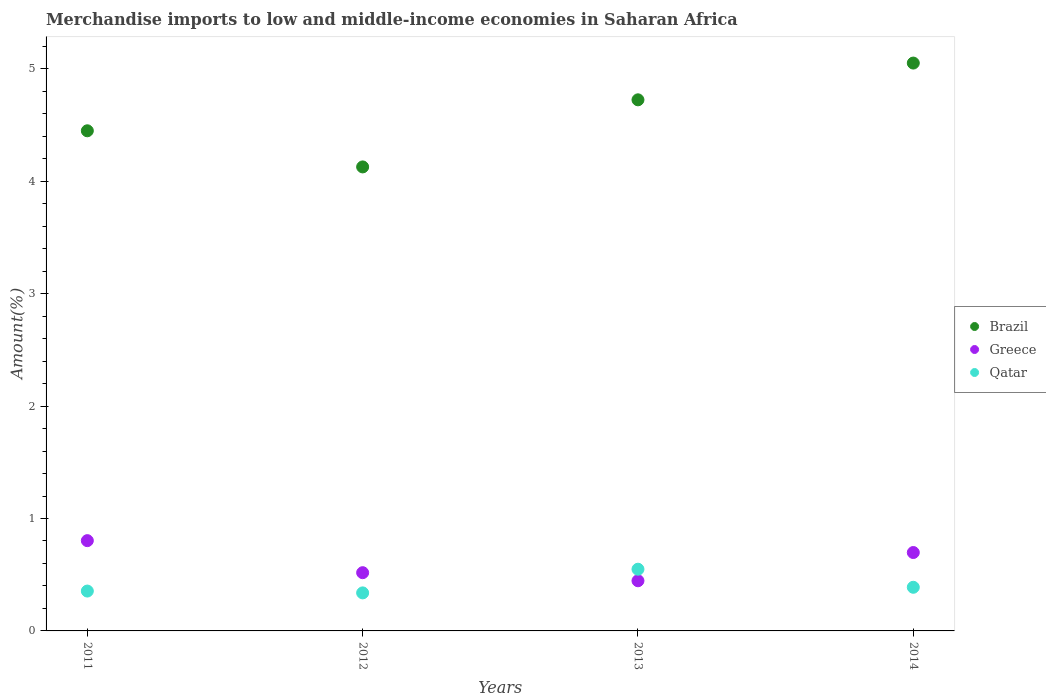How many different coloured dotlines are there?
Provide a succinct answer. 3. Is the number of dotlines equal to the number of legend labels?
Offer a very short reply. Yes. What is the percentage of amount earned from merchandise imports in Qatar in 2014?
Keep it short and to the point. 0.39. Across all years, what is the maximum percentage of amount earned from merchandise imports in Greece?
Keep it short and to the point. 0.8. Across all years, what is the minimum percentage of amount earned from merchandise imports in Greece?
Keep it short and to the point. 0.45. What is the total percentage of amount earned from merchandise imports in Qatar in the graph?
Provide a succinct answer. 1.63. What is the difference between the percentage of amount earned from merchandise imports in Qatar in 2012 and that in 2013?
Provide a short and direct response. -0.21. What is the difference between the percentage of amount earned from merchandise imports in Brazil in 2011 and the percentage of amount earned from merchandise imports in Qatar in 2013?
Offer a very short reply. 3.9. What is the average percentage of amount earned from merchandise imports in Greece per year?
Keep it short and to the point. 0.62. In the year 2013, what is the difference between the percentage of amount earned from merchandise imports in Qatar and percentage of amount earned from merchandise imports in Greece?
Your answer should be very brief. 0.1. In how many years, is the percentage of amount earned from merchandise imports in Greece greater than 4 %?
Your answer should be compact. 0. What is the ratio of the percentage of amount earned from merchandise imports in Brazil in 2012 to that in 2014?
Your answer should be compact. 0.82. Is the percentage of amount earned from merchandise imports in Qatar in 2012 less than that in 2014?
Provide a succinct answer. Yes. Is the difference between the percentage of amount earned from merchandise imports in Qatar in 2012 and 2014 greater than the difference between the percentage of amount earned from merchandise imports in Greece in 2012 and 2014?
Your answer should be very brief. Yes. What is the difference between the highest and the second highest percentage of amount earned from merchandise imports in Greece?
Ensure brevity in your answer.  0.11. What is the difference between the highest and the lowest percentage of amount earned from merchandise imports in Qatar?
Offer a very short reply. 0.21. Does the percentage of amount earned from merchandise imports in Greece monotonically increase over the years?
Ensure brevity in your answer.  No. Is the percentage of amount earned from merchandise imports in Brazil strictly less than the percentage of amount earned from merchandise imports in Qatar over the years?
Your response must be concise. No. How many years are there in the graph?
Your answer should be compact. 4. Are the values on the major ticks of Y-axis written in scientific E-notation?
Keep it short and to the point. No. Does the graph contain any zero values?
Offer a terse response. No. Where does the legend appear in the graph?
Offer a terse response. Center right. How many legend labels are there?
Provide a short and direct response. 3. How are the legend labels stacked?
Provide a short and direct response. Vertical. What is the title of the graph?
Ensure brevity in your answer.  Merchandise imports to low and middle-income economies in Saharan Africa. What is the label or title of the Y-axis?
Ensure brevity in your answer.  Amount(%). What is the Amount(%) of Brazil in 2011?
Provide a succinct answer. 4.45. What is the Amount(%) of Greece in 2011?
Provide a short and direct response. 0.8. What is the Amount(%) of Qatar in 2011?
Your response must be concise. 0.35. What is the Amount(%) of Brazil in 2012?
Offer a very short reply. 4.13. What is the Amount(%) of Greece in 2012?
Your answer should be compact. 0.52. What is the Amount(%) of Qatar in 2012?
Your answer should be very brief. 0.34. What is the Amount(%) of Brazil in 2013?
Your answer should be very brief. 4.72. What is the Amount(%) of Greece in 2013?
Keep it short and to the point. 0.45. What is the Amount(%) in Qatar in 2013?
Offer a terse response. 0.55. What is the Amount(%) of Brazil in 2014?
Your answer should be very brief. 5.05. What is the Amount(%) of Greece in 2014?
Ensure brevity in your answer.  0.7. What is the Amount(%) of Qatar in 2014?
Give a very brief answer. 0.39. Across all years, what is the maximum Amount(%) in Brazil?
Your answer should be very brief. 5.05. Across all years, what is the maximum Amount(%) in Greece?
Your response must be concise. 0.8. Across all years, what is the maximum Amount(%) in Qatar?
Keep it short and to the point. 0.55. Across all years, what is the minimum Amount(%) of Brazil?
Provide a succinct answer. 4.13. Across all years, what is the minimum Amount(%) in Greece?
Provide a short and direct response. 0.45. Across all years, what is the minimum Amount(%) of Qatar?
Provide a short and direct response. 0.34. What is the total Amount(%) in Brazil in the graph?
Keep it short and to the point. 18.35. What is the total Amount(%) in Greece in the graph?
Your response must be concise. 2.46. What is the total Amount(%) in Qatar in the graph?
Offer a terse response. 1.63. What is the difference between the Amount(%) in Brazil in 2011 and that in 2012?
Provide a succinct answer. 0.32. What is the difference between the Amount(%) of Greece in 2011 and that in 2012?
Provide a succinct answer. 0.28. What is the difference between the Amount(%) in Qatar in 2011 and that in 2012?
Offer a very short reply. 0.02. What is the difference between the Amount(%) of Brazil in 2011 and that in 2013?
Your response must be concise. -0.28. What is the difference between the Amount(%) of Greece in 2011 and that in 2013?
Ensure brevity in your answer.  0.36. What is the difference between the Amount(%) in Qatar in 2011 and that in 2013?
Keep it short and to the point. -0.19. What is the difference between the Amount(%) in Brazil in 2011 and that in 2014?
Your response must be concise. -0.6. What is the difference between the Amount(%) in Greece in 2011 and that in 2014?
Provide a short and direct response. 0.11. What is the difference between the Amount(%) of Qatar in 2011 and that in 2014?
Provide a succinct answer. -0.03. What is the difference between the Amount(%) in Brazil in 2012 and that in 2013?
Provide a short and direct response. -0.6. What is the difference between the Amount(%) of Greece in 2012 and that in 2013?
Give a very brief answer. 0.07. What is the difference between the Amount(%) in Qatar in 2012 and that in 2013?
Offer a very short reply. -0.21. What is the difference between the Amount(%) in Brazil in 2012 and that in 2014?
Keep it short and to the point. -0.92. What is the difference between the Amount(%) in Greece in 2012 and that in 2014?
Offer a very short reply. -0.18. What is the difference between the Amount(%) of Qatar in 2012 and that in 2014?
Your answer should be very brief. -0.05. What is the difference between the Amount(%) of Brazil in 2013 and that in 2014?
Ensure brevity in your answer.  -0.33. What is the difference between the Amount(%) in Greece in 2013 and that in 2014?
Ensure brevity in your answer.  -0.25. What is the difference between the Amount(%) in Qatar in 2013 and that in 2014?
Make the answer very short. 0.16. What is the difference between the Amount(%) in Brazil in 2011 and the Amount(%) in Greece in 2012?
Your response must be concise. 3.93. What is the difference between the Amount(%) of Brazil in 2011 and the Amount(%) of Qatar in 2012?
Keep it short and to the point. 4.11. What is the difference between the Amount(%) of Greece in 2011 and the Amount(%) of Qatar in 2012?
Offer a very short reply. 0.46. What is the difference between the Amount(%) of Brazil in 2011 and the Amount(%) of Greece in 2013?
Ensure brevity in your answer.  4. What is the difference between the Amount(%) in Brazil in 2011 and the Amount(%) in Qatar in 2013?
Provide a succinct answer. 3.9. What is the difference between the Amount(%) of Greece in 2011 and the Amount(%) of Qatar in 2013?
Keep it short and to the point. 0.25. What is the difference between the Amount(%) in Brazil in 2011 and the Amount(%) in Greece in 2014?
Offer a terse response. 3.75. What is the difference between the Amount(%) in Brazil in 2011 and the Amount(%) in Qatar in 2014?
Keep it short and to the point. 4.06. What is the difference between the Amount(%) in Greece in 2011 and the Amount(%) in Qatar in 2014?
Make the answer very short. 0.41. What is the difference between the Amount(%) in Brazil in 2012 and the Amount(%) in Greece in 2013?
Your answer should be very brief. 3.68. What is the difference between the Amount(%) of Brazil in 2012 and the Amount(%) of Qatar in 2013?
Offer a very short reply. 3.58. What is the difference between the Amount(%) of Greece in 2012 and the Amount(%) of Qatar in 2013?
Your answer should be very brief. -0.03. What is the difference between the Amount(%) of Brazil in 2012 and the Amount(%) of Greece in 2014?
Offer a very short reply. 3.43. What is the difference between the Amount(%) of Brazil in 2012 and the Amount(%) of Qatar in 2014?
Your answer should be compact. 3.74. What is the difference between the Amount(%) in Greece in 2012 and the Amount(%) in Qatar in 2014?
Provide a succinct answer. 0.13. What is the difference between the Amount(%) of Brazil in 2013 and the Amount(%) of Greece in 2014?
Your answer should be compact. 4.03. What is the difference between the Amount(%) of Brazil in 2013 and the Amount(%) of Qatar in 2014?
Provide a succinct answer. 4.34. What is the difference between the Amount(%) of Greece in 2013 and the Amount(%) of Qatar in 2014?
Your response must be concise. 0.06. What is the average Amount(%) in Brazil per year?
Make the answer very short. 4.59. What is the average Amount(%) of Greece per year?
Provide a succinct answer. 0.62. What is the average Amount(%) in Qatar per year?
Give a very brief answer. 0.41. In the year 2011, what is the difference between the Amount(%) in Brazil and Amount(%) in Greece?
Offer a very short reply. 3.65. In the year 2011, what is the difference between the Amount(%) in Brazil and Amount(%) in Qatar?
Ensure brevity in your answer.  4.09. In the year 2011, what is the difference between the Amount(%) of Greece and Amount(%) of Qatar?
Offer a very short reply. 0.45. In the year 2012, what is the difference between the Amount(%) in Brazil and Amount(%) in Greece?
Offer a very short reply. 3.61. In the year 2012, what is the difference between the Amount(%) of Brazil and Amount(%) of Qatar?
Your answer should be compact. 3.79. In the year 2012, what is the difference between the Amount(%) of Greece and Amount(%) of Qatar?
Give a very brief answer. 0.18. In the year 2013, what is the difference between the Amount(%) of Brazil and Amount(%) of Greece?
Ensure brevity in your answer.  4.28. In the year 2013, what is the difference between the Amount(%) in Brazil and Amount(%) in Qatar?
Your response must be concise. 4.18. In the year 2013, what is the difference between the Amount(%) in Greece and Amount(%) in Qatar?
Offer a very short reply. -0.1. In the year 2014, what is the difference between the Amount(%) in Brazil and Amount(%) in Greece?
Provide a succinct answer. 4.35. In the year 2014, what is the difference between the Amount(%) in Brazil and Amount(%) in Qatar?
Your answer should be compact. 4.66. In the year 2014, what is the difference between the Amount(%) of Greece and Amount(%) of Qatar?
Offer a terse response. 0.31. What is the ratio of the Amount(%) in Brazil in 2011 to that in 2012?
Provide a succinct answer. 1.08. What is the ratio of the Amount(%) of Greece in 2011 to that in 2012?
Make the answer very short. 1.55. What is the ratio of the Amount(%) in Qatar in 2011 to that in 2012?
Offer a terse response. 1.05. What is the ratio of the Amount(%) in Brazil in 2011 to that in 2013?
Ensure brevity in your answer.  0.94. What is the ratio of the Amount(%) of Greece in 2011 to that in 2013?
Your response must be concise. 1.8. What is the ratio of the Amount(%) in Qatar in 2011 to that in 2013?
Your response must be concise. 0.65. What is the ratio of the Amount(%) in Brazil in 2011 to that in 2014?
Your response must be concise. 0.88. What is the ratio of the Amount(%) of Greece in 2011 to that in 2014?
Offer a very short reply. 1.15. What is the ratio of the Amount(%) of Qatar in 2011 to that in 2014?
Your answer should be compact. 0.91. What is the ratio of the Amount(%) of Brazil in 2012 to that in 2013?
Your answer should be very brief. 0.87. What is the ratio of the Amount(%) of Greece in 2012 to that in 2013?
Give a very brief answer. 1.16. What is the ratio of the Amount(%) of Qatar in 2012 to that in 2013?
Give a very brief answer. 0.62. What is the ratio of the Amount(%) of Brazil in 2012 to that in 2014?
Your answer should be very brief. 0.82. What is the ratio of the Amount(%) in Greece in 2012 to that in 2014?
Make the answer very short. 0.74. What is the ratio of the Amount(%) in Qatar in 2012 to that in 2014?
Ensure brevity in your answer.  0.87. What is the ratio of the Amount(%) in Brazil in 2013 to that in 2014?
Give a very brief answer. 0.94. What is the ratio of the Amount(%) of Greece in 2013 to that in 2014?
Provide a succinct answer. 0.64. What is the ratio of the Amount(%) in Qatar in 2013 to that in 2014?
Your answer should be compact. 1.41. What is the difference between the highest and the second highest Amount(%) in Brazil?
Your response must be concise. 0.33. What is the difference between the highest and the second highest Amount(%) in Greece?
Give a very brief answer. 0.11. What is the difference between the highest and the second highest Amount(%) in Qatar?
Provide a short and direct response. 0.16. What is the difference between the highest and the lowest Amount(%) of Brazil?
Keep it short and to the point. 0.92. What is the difference between the highest and the lowest Amount(%) of Greece?
Your answer should be very brief. 0.36. What is the difference between the highest and the lowest Amount(%) in Qatar?
Your answer should be compact. 0.21. 